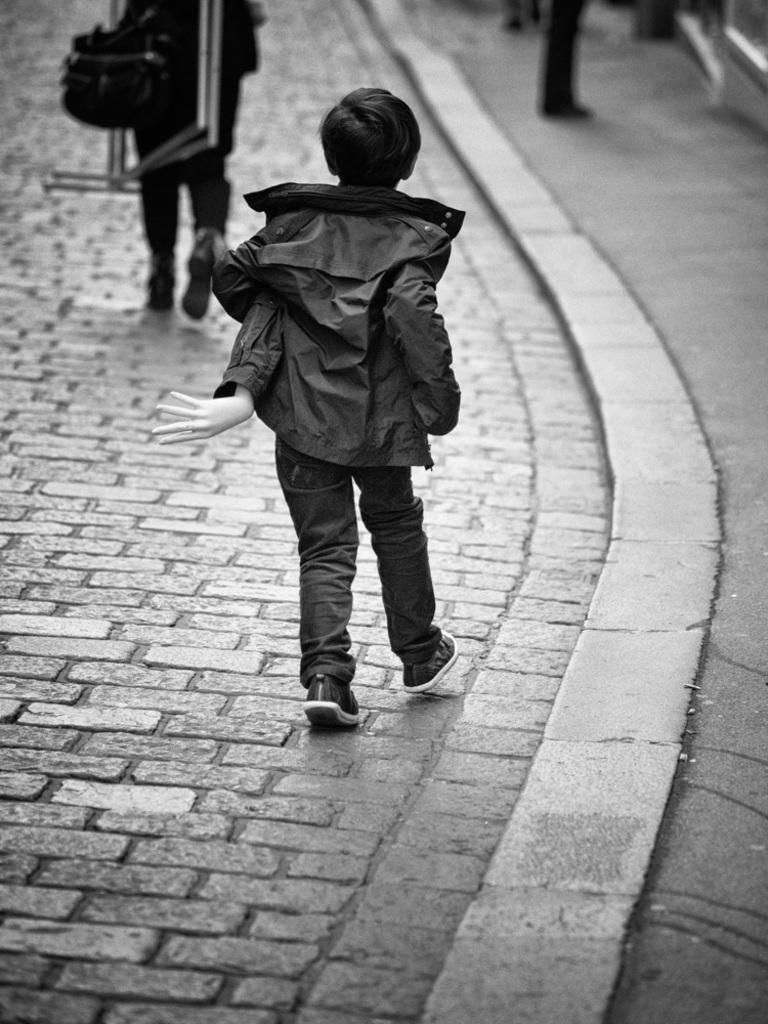What is the color scheme of the image? The image is black and white. Who is present in the image? There is a boy in the image. What is the boy wearing? The boy is wearing a jacket. How is the background of the image depicted? The background of the image is blurred. Can you describe the people in the image? There are people in the image, and one of them is holding objects. What type of chair is the boy sitting on in the image? There is no chair present in the image, and the boy is not sitting down. 